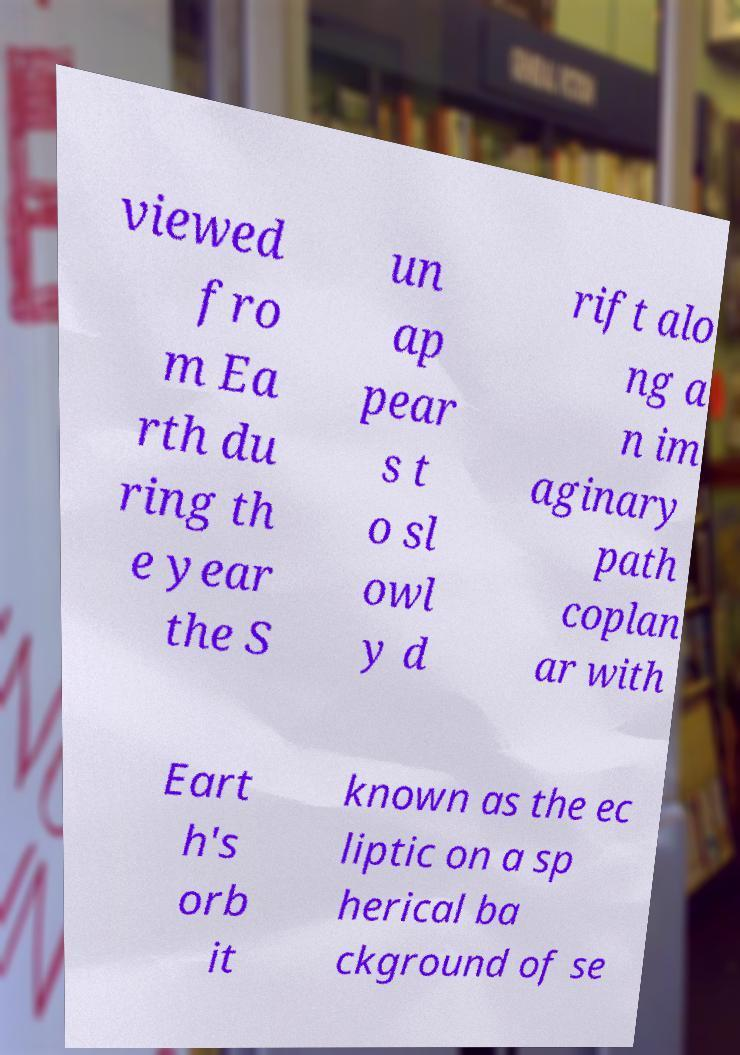What messages or text are displayed in this image? I need them in a readable, typed format. viewed fro m Ea rth du ring th e year the S un ap pear s t o sl owl y d rift alo ng a n im aginary path coplan ar with Eart h's orb it known as the ec liptic on a sp herical ba ckground of se 